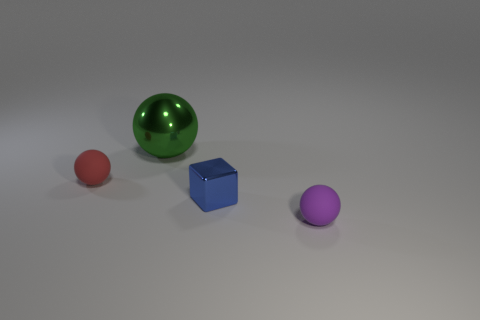Subtract all small balls. How many balls are left? 1 Subtract all purple balls. How many balls are left? 2 Subtract all balls. How many objects are left? 1 Add 1 shiny balls. How many shiny balls are left? 2 Add 1 large green objects. How many large green objects exist? 2 Add 4 large cyan metallic balls. How many objects exist? 8 Subtract 0 brown cylinders. How many objects are left? 4 Subtract 1 cubes. How many cubes are left? 0 Subtract all blue spheres. Subtract all green cylinders. How many spheres are left? 3 Subtract all purple cylinders. How many purple spheres are left? 1 